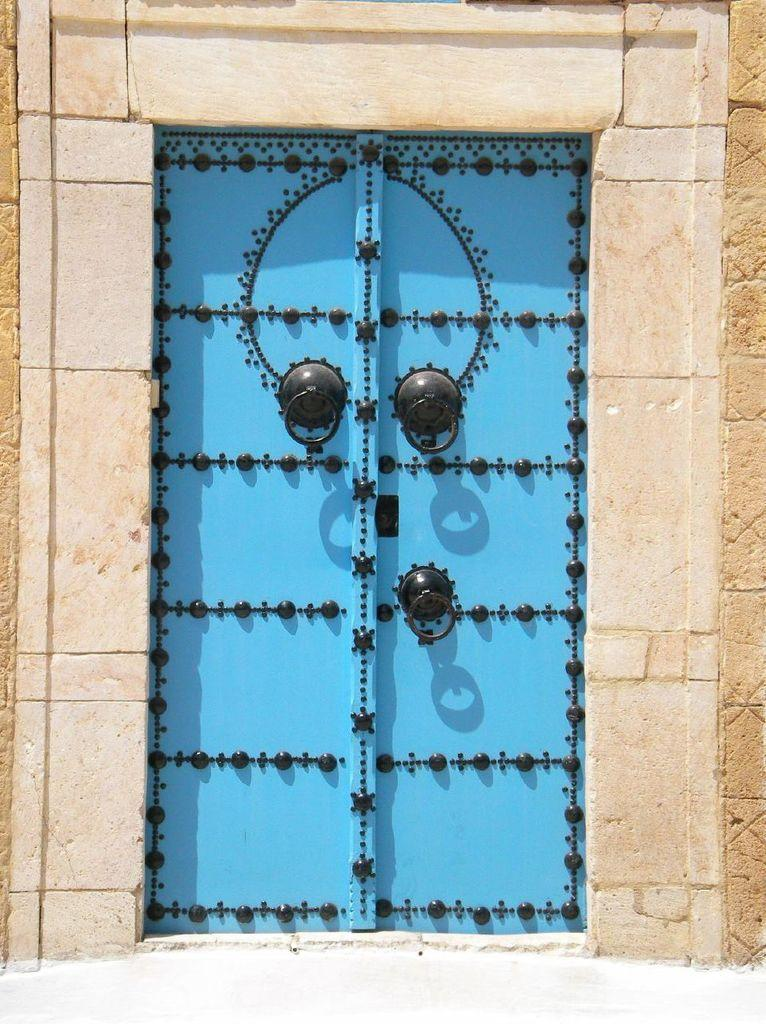What type of structure can be seen in the image? There is a wall in the image. What is the color of the door on the wall? There is a blue door in the image. What type of punishment is being handed out in the image? There is no indication of punishment in the image; it only features a wall and a blue door. What type of agreement is being signed in the image? There is no indication of an agreement or signing in the image; it only features a wall and a blue door. 